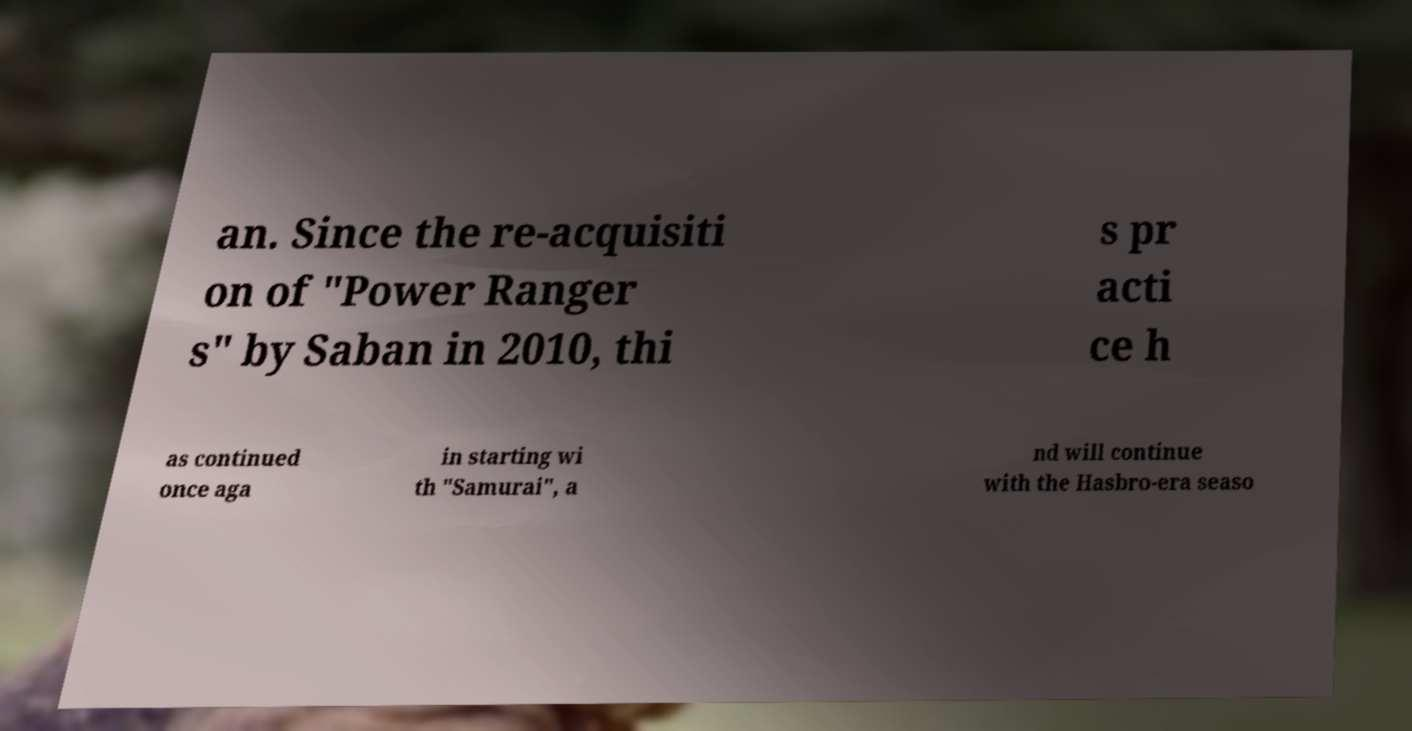Could you extract and type out the text from this image? an. Since the re-acquisiti on of "Power Ranger s" by Saban in 2010, thi s pr acti ce h as continued once aga in starting wi th "Samurai", a nd will continue with the Hasbro-era seaso 